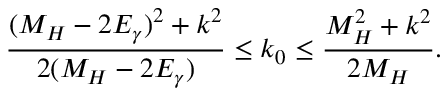<formula> <loc_0><loc_0><loc_500><loc_500>\frac { ( M _ { H } - 2 E _ { \gamma } ) ^ { 2 } + k ^ { 2 } } { 2 ( M _ { H } - 2 E _ { \gamma } ) } \leq k _ { 0 } \leq \frac { M _ { H } ^ { 2 } + k ^ { 2 } } { 2 M _ { H } } .</formula> 